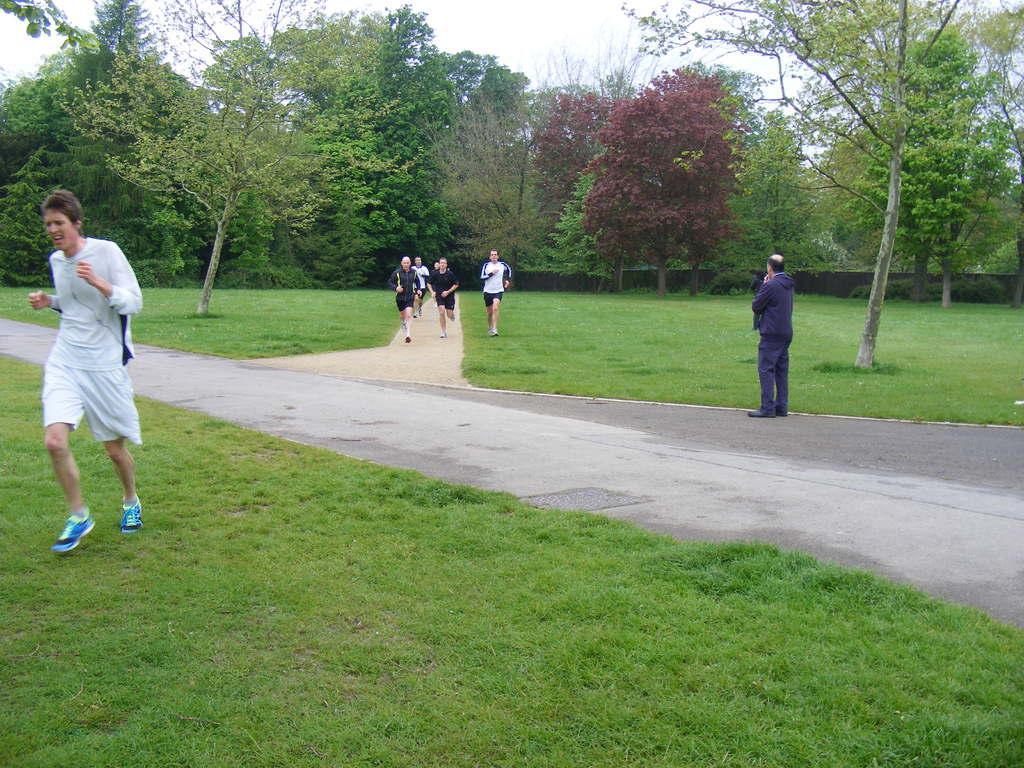Can you describe this image briefly? This image is taken outdoors. At the bottom of the image there is a road and a ground with grass on it. In the background there are many trees. On the right side of the image a man is running on the ground. On the right side of the image a man is standing on the road. In the middle of the image a few people are running on the road. 